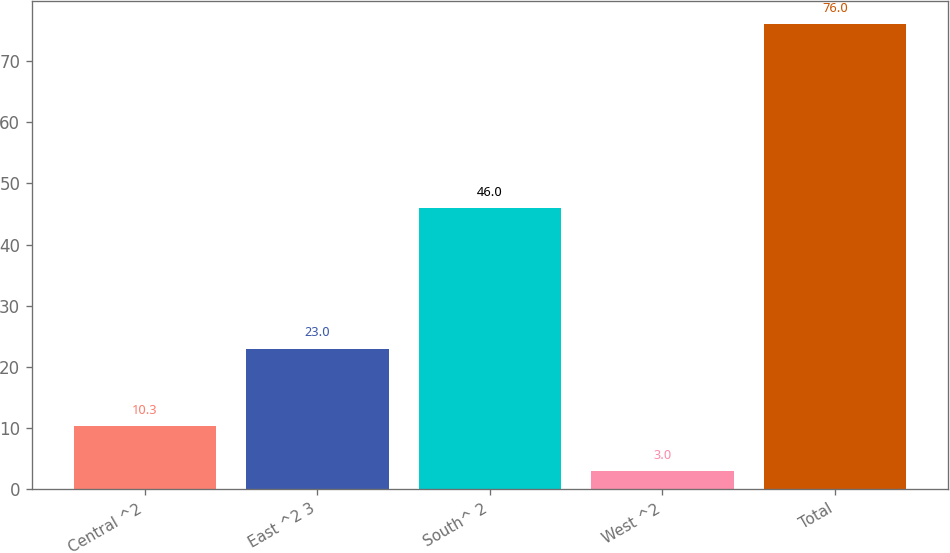Convert chart to OTSL. <chart><loc_0><loc_0><loc_500><loc_500><bar_chart><fcel>Central ^2<fcel>East ^2 3<fcel>South^ 2<fcel>West ^2<fcel>Total<nl><fcel>10.3<fcel>23<fcel>46<fcel>3<fcel>76<nl></chart> 